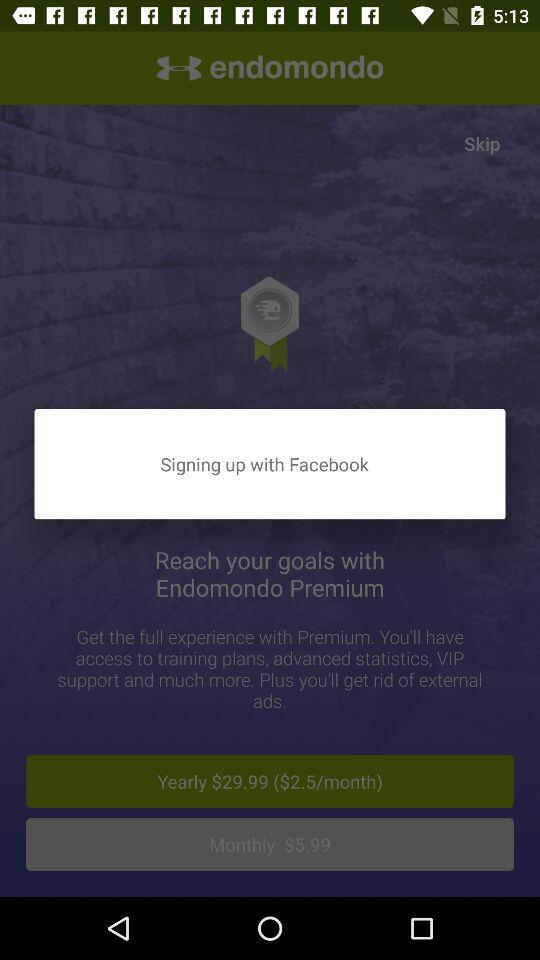What is the application name? The application name is "endomondo". 